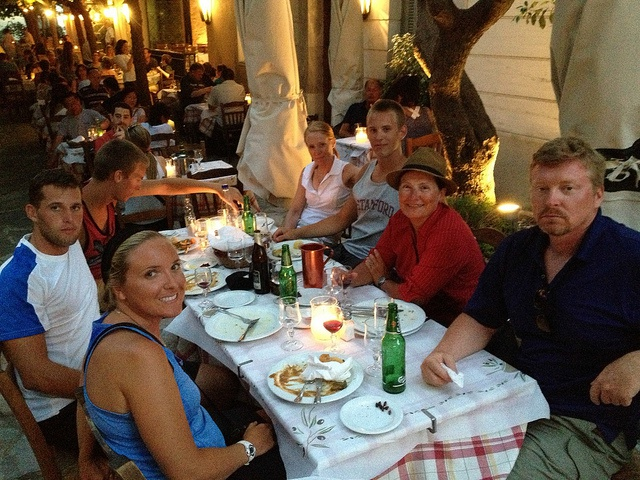Describe the objects in this image and their specific colors. I can see people in black, gray, and maroon tones, people in black, maroon, and brown tones, dining table in black, lightgray, darkgray, and lightblue tones, people in black, maroon, darkgray, and navy tones, and dining table in black, lightblue, and darkgray tones in this image. 